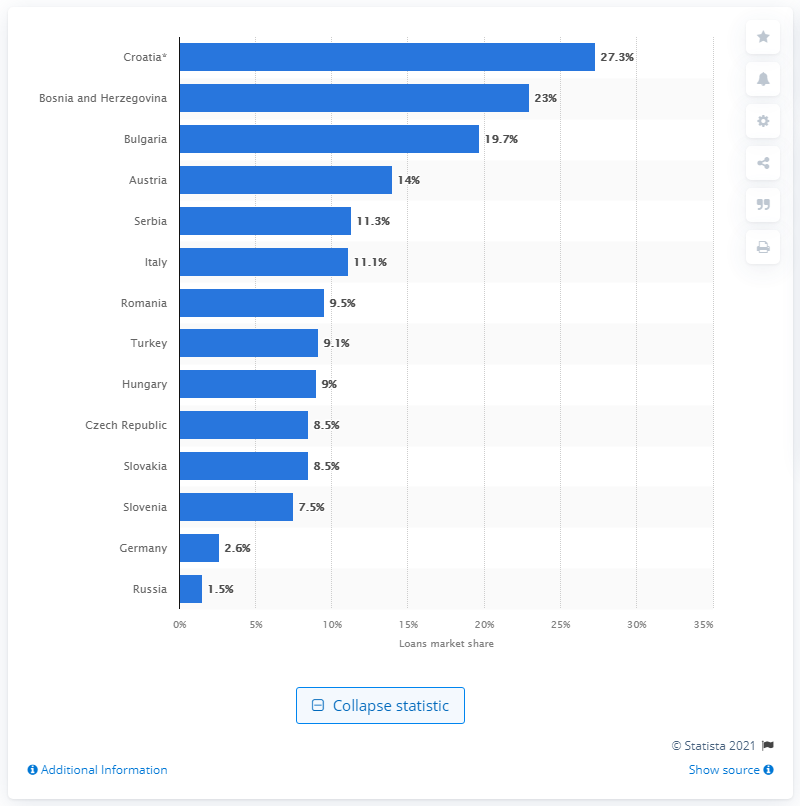Point out several critical features in this image. UniCredit's loans held a market share of approximately 23% in Bosnia and Herzegovina in 2017. 